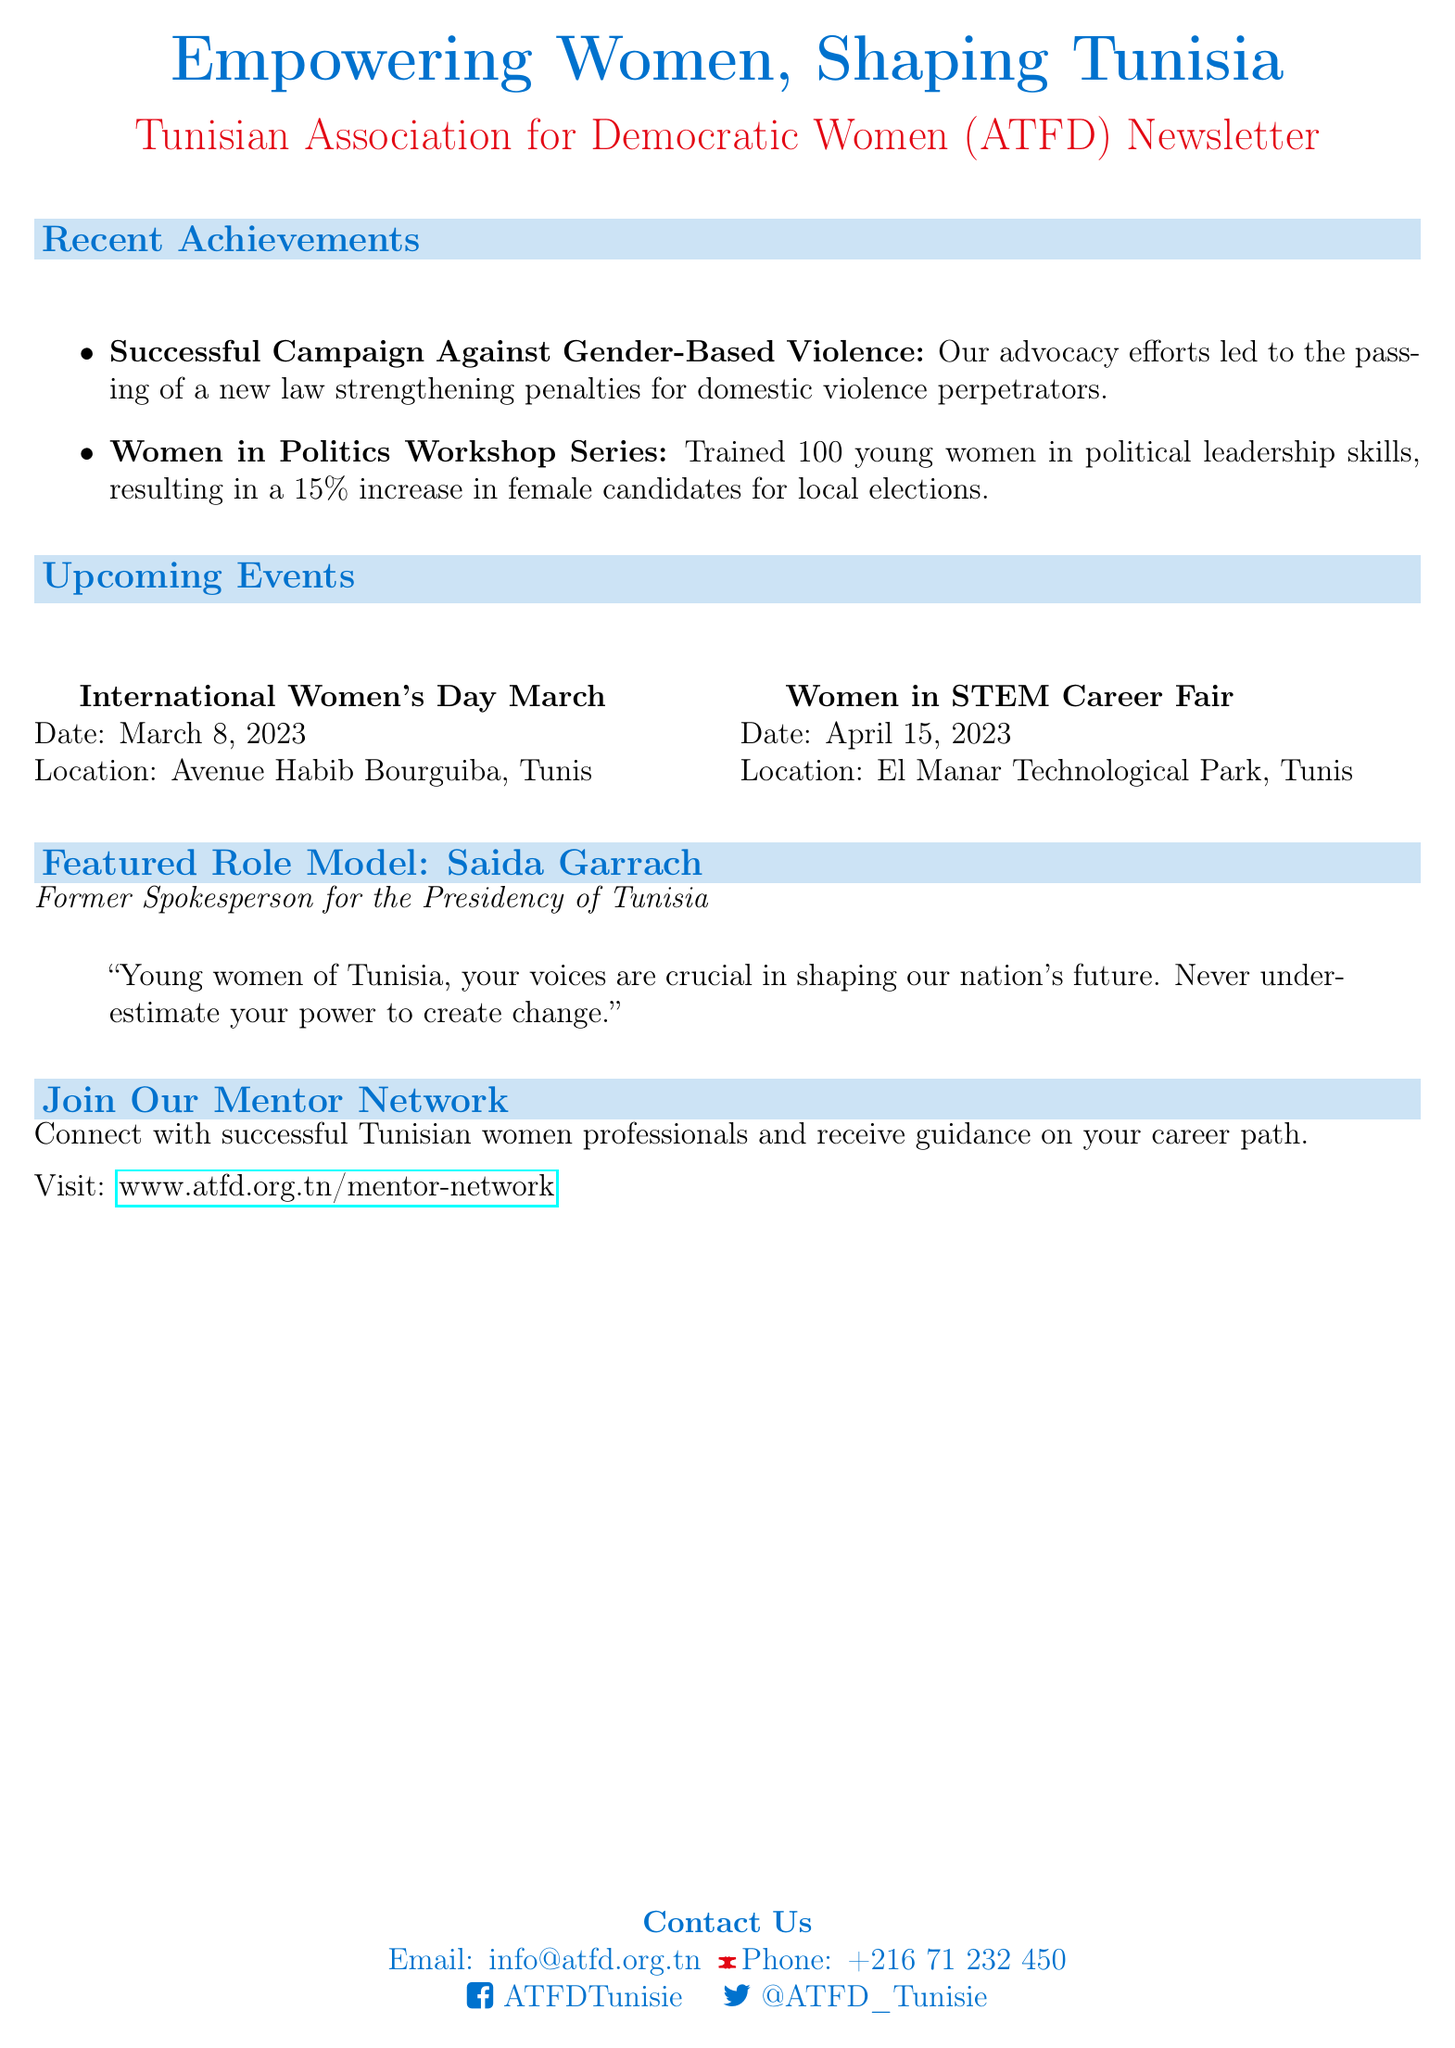What is the title of the newsletter? The title of the newsletter is given at the beginning of the document, emphasizing the theme of empowerment and women's rights.
Answer: Empowering Women, Shaping Tunisia Who is the featured role model in the newsletter? The newsletter highlights a specific individual to inspire readers, mentioned in the section for the role model.
Answer: Saida Garrach What date is the International Women's Day March scheduled for? The date for the upcoming event is explicitly stated in the event section of the document.
Answer: March 8, 2023 What percentage increase in female candidates for local elections resulted from the Women in Politics Workshop Series? The document indicates the result of this workshop series in terms of a percentage related to female political candidates.
Answer: 15% What does the call to action invite readers to join? This part of the newsletter encourages readers to engage with a specific initiative mentioned in the call to action section.
Answer: Mentor Network What is one of the recent achievements listed in the newsletter? The section of recent achievements details notable accomplishments of the organization, highlighting specific campaigns or workshops.
Answer: Successful Campaign Against Gender-Based Violence Where is the Women in STEM Career Fair taking place? The location of this upcoming event is included in the information provided about each event in the document.
Answer: El Manar Technological Park, Tunis What is the email address for contacting the organization? The document provides contact information, including an email address for further inquiries.
Answer: info@atfd.org.tn 